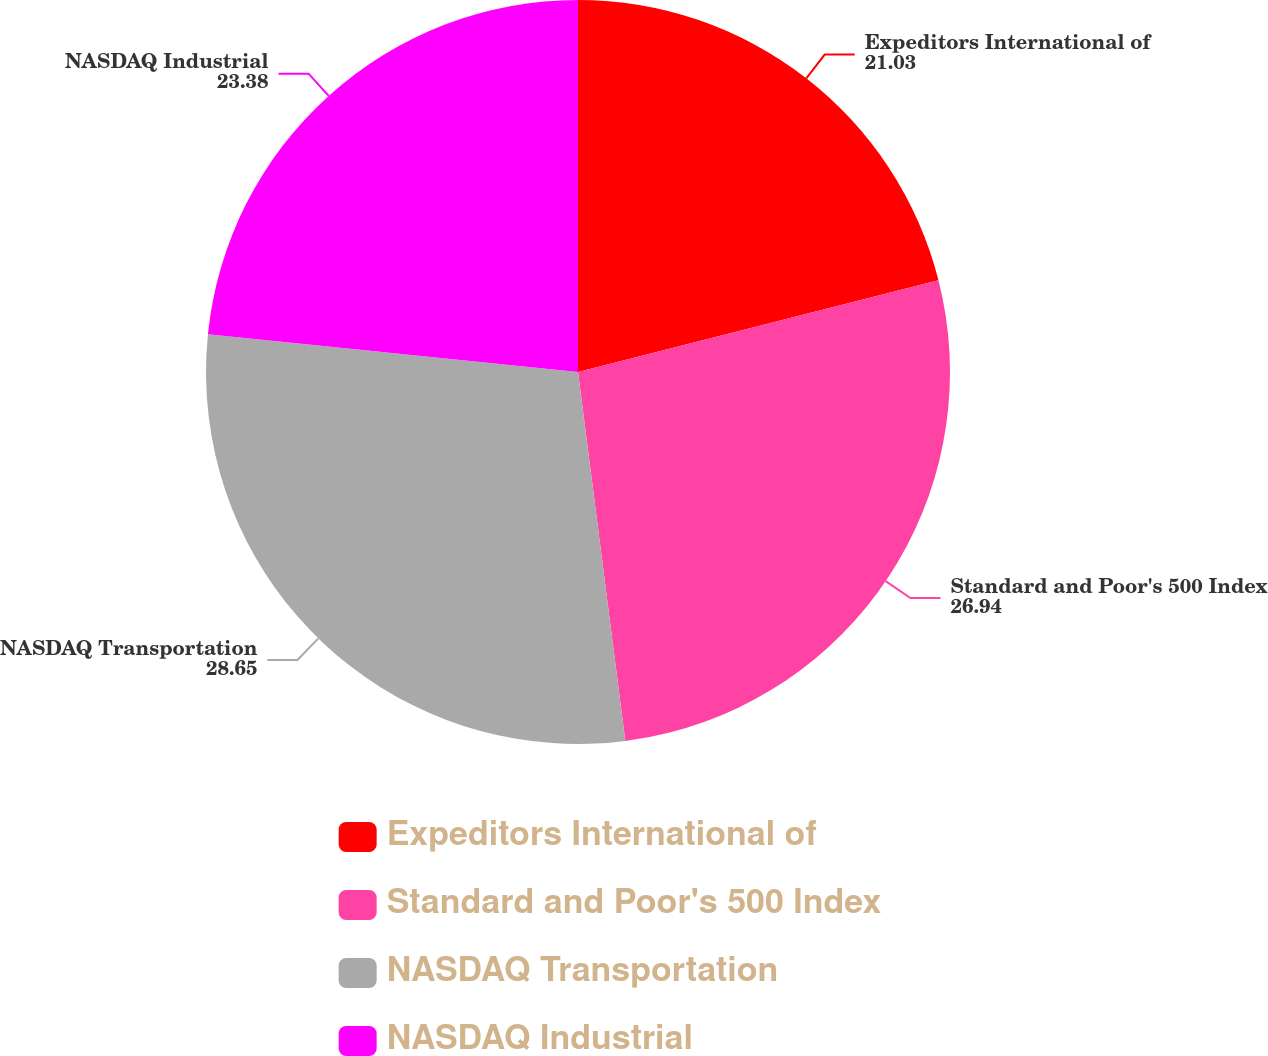Convert chart to OTSL. <chart><loc_0><loc_0><loc_500><loc_500><pie_chart><fcel>Expeditors International of<fcel>Standard and Poor's 500 Index<fcel>NASDAQ Transportation<fcel>NASDAQ Industrial<nl><fcel>21.03%<fcel>26.94%<fcel>28.65%<fcel>23.38%<nl></chart> 